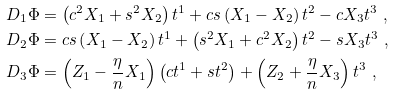Convert formula to latex. <formula><loc_0><loc_0><loc_500><loc_500>D _ { 1 } \Phi & = \left ( c ^ { 2 } X _ { 1 } + s ^ { 2 } X _ { 2 } \right ) t ^ { 1 } + c s \left ( X _ { 1 } - X _ { 2 } \right ) t ^ { 2 } - c X _ { 3 } t ^ { 3 } \ , \\ D _ { 2 } \Phi & = c s \left ( X _ { 1 } - X _ { 2 } \right ) t ^ { 1 } + \left ( s ^ { 2 } X _ { 1 } + c ^ { 2 } X _ { 2 } \right ) t ^ { 2 } - s X _ { 3 } t ^ { 3 } \ , \\ D _ { 3 } \Phi & = \left ( Z _ { 1 } - \frac { \eta } { n } X _ { 1 } \right ) \left ( c t ^ { 1 } + s t ^ { 2 } \right ) + \left ( Z _ { 2 } + \frac { \eta } { n } X _ { 3 } \right ) t ^ { 3 } \ ,</formula> 